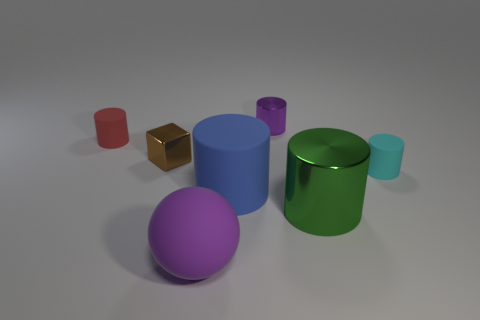Subtract 1 cylinders. How many cylinders are left? 4 Subtract all blue cylinders. How many cylinders are left? 4 Subtract all red cylinders. How many cylinders are left? 4 Add 1 cyan rubber objects. How many objects exist? 8 Subtract all blue cylinders. Subtract all purple spheres. How many cylinders are left? 4 Subtract all balls. How many objects are left? 6 Add 4 big purple things. How many big purple things exist? 5 Subtract 0 yellow cylinders. How many objects are left? 7 Subtract all green rubber balls. Subtract all big green metal objects. How many objects are left? 6 Add 2 shiny cylinders. How many shiny cylinders are left? 4 